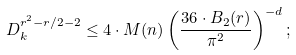Convert formula to latex. <formula><loc_0><loc_0><loc_500><loc_500>\ D _ { k } ^ { r ^ { 2 } - r / 2 - 2 } \leq 4 \cdot M ( n ) \left ( \frac { 3 6 \cdot B _ { 2 } ( r ) } { \pi ^ { 2 } } \right ) ^ { - d } ;</formula> 